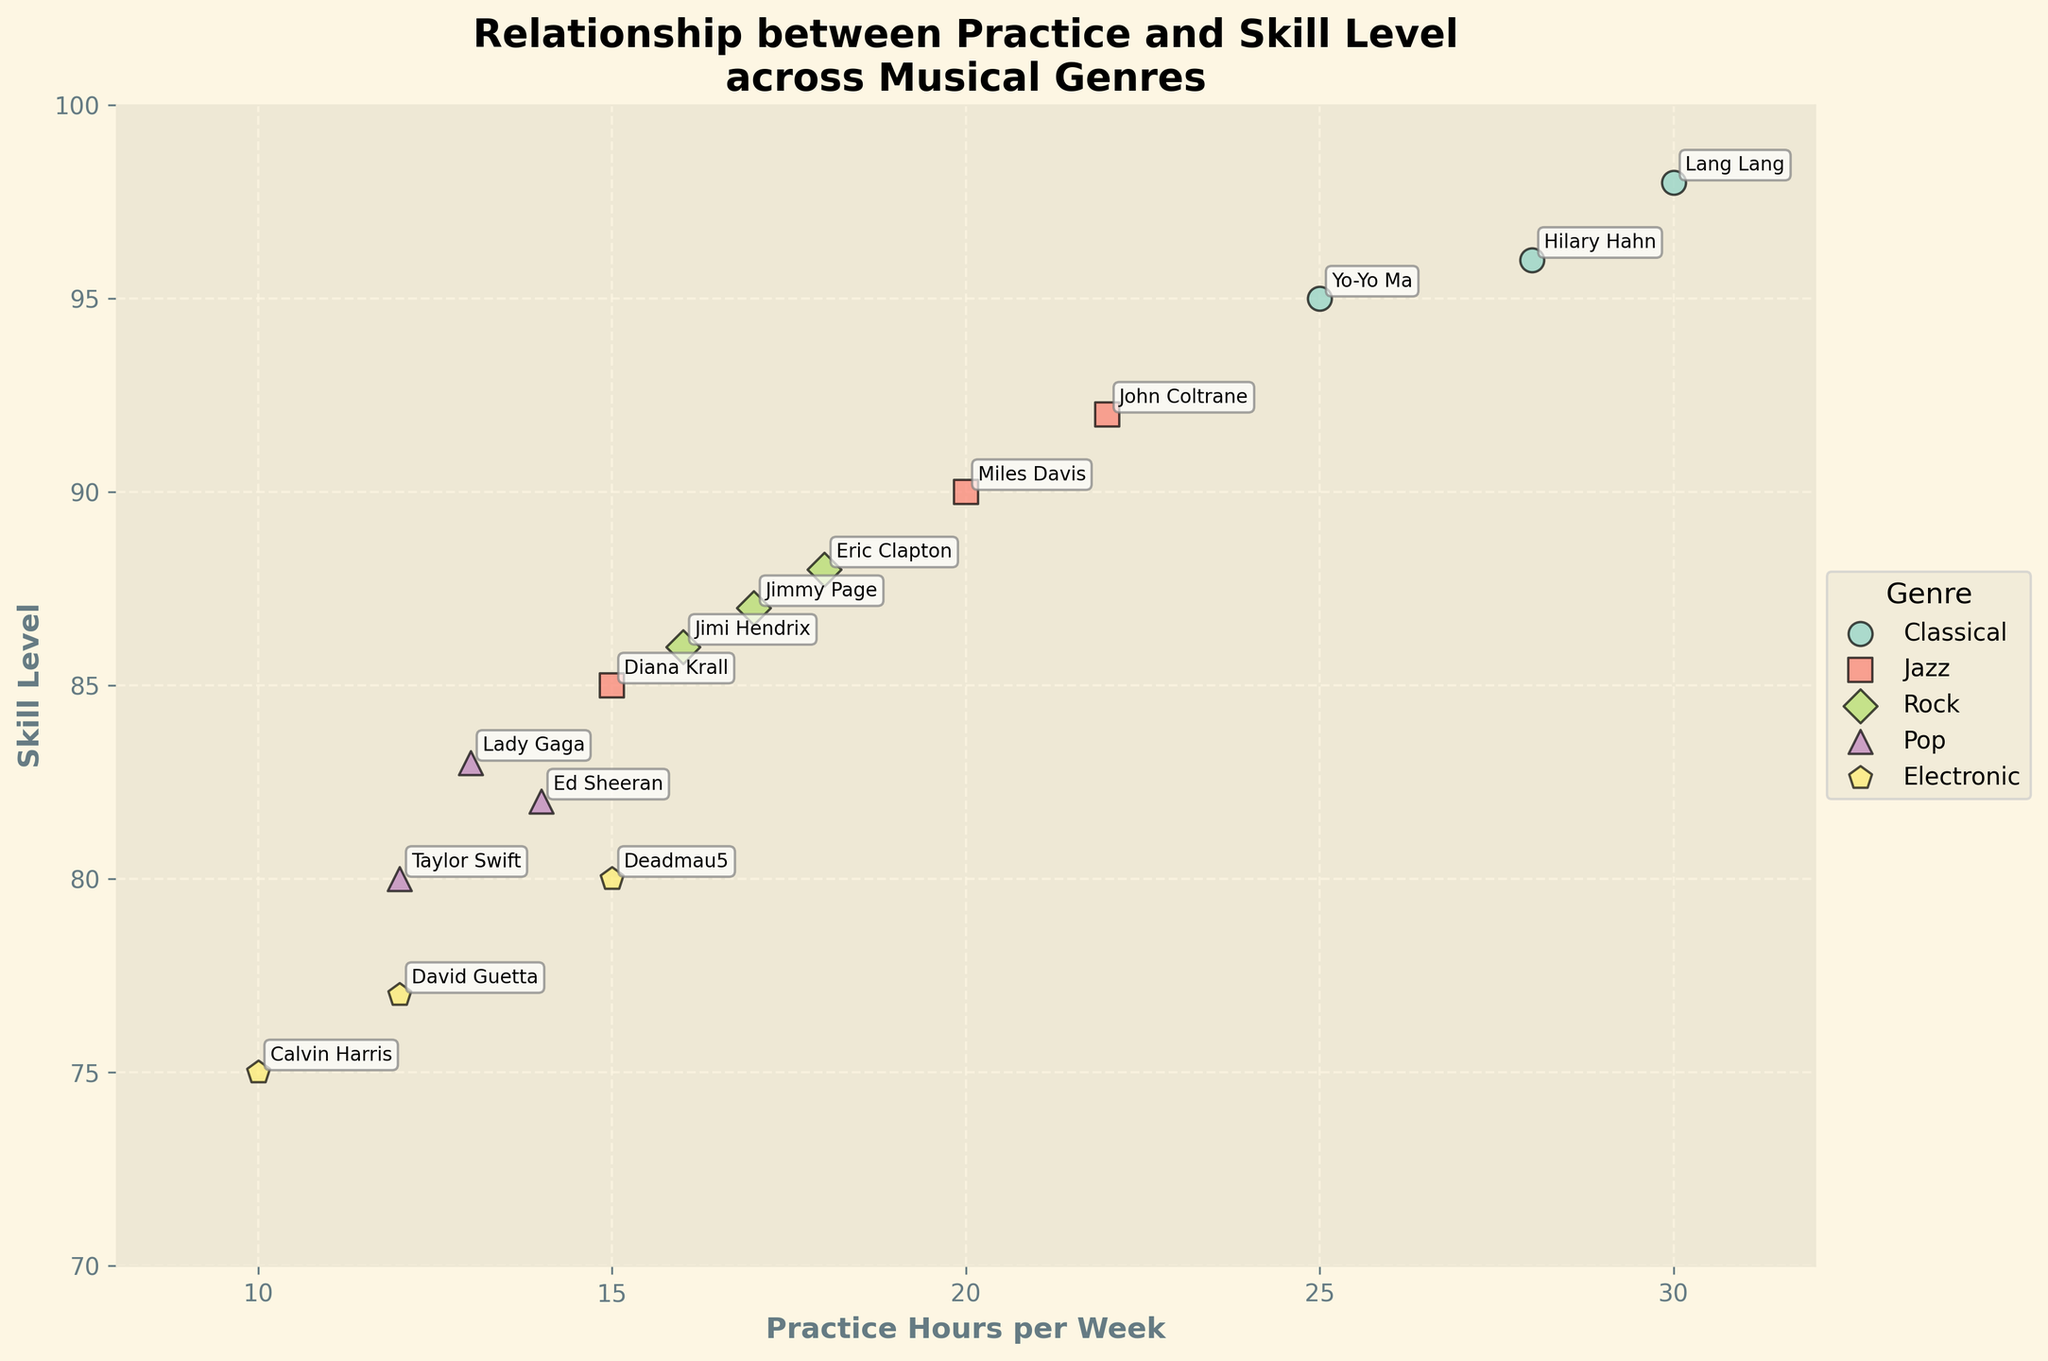What is the title of the subplot? The title of the figure is typically displayed at the top. "Relationship between Practice and Skill Level across Musical Genres" is written in a bold, large font at the top of the subplot.
Answer: "Relationship between Practice and Skill Level across Musical Genres" How many genres are represented in the scatter plot? The legend on the right side of the plot lists the genres. The genres can be counted visually from the legend. There are five genres listed: Classical, Jazz, Rock, Pop, and Electronic.
Answer: 5 Which genre shows the highest skill level? By scanning the scatter plot, the highest point in the vertical direction (representing skill level) belongs to an individual from the Classical genre. The highest skill level among Classical musicians is around 98.
Answer: Classical Which musician practices the most hours per week? Look for the data point farthest right on the horizontal axis. Lang Lang, a Classical musician, is marked at the position corresponding to 30 hours of practice per week.
Answer: Lang Lang What's the practice hour range for Jazz musicians? Observe the horizontal spread of the points labeled as Jazz musicians. Miles Davis (20 hours) and John Coltrane (22 hours) have the highest hours, while Diana Krall has the lowest at 15 hours.
Answer: 15-22 hours Is there any musician in the Pop genre with a skill level above 85? Observe the scatter plot markers labeled with Pop performers. The highest skill level among them is Lady Gaga with 83, which is below 85.
Answer: No Which genre has a musician with the lowest practice hours? The data point farthest to the left should be identified. Calvin Harris from the Electronic genre is marked at 10 hours per week.
Answer: Electronic Compare the practice hours between Eric Clapton and Jimi Hendrix. Who practices more? Locate the points representing Eric Clapton and Jimi Hendrix and compare their positions on the horizontal axis. Eric Clapton practices at 18 hours while Jimi Hendrix practices at 16 hours per week.
Answer: Eric Clapton What is the difference in skill level between Taylor Swift and Deadmau5? Identify Taylor Swift and Deadmau5 on the plot and note their respective skill levels, which are 80 and 80. The difference can be calculated as 80 - 75 = 5.
Answer: 5 Which genre shows the most consistent practice hours and how can you tell? Consistency can be judged by the spread of the data points on the horizontal axis for each genre. Jazz musicians, with practice hours ranging closely between 15-22 hours, show high consistency compared to other genres.
Answer: Jazz 